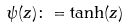<formula> <loc_0><loc_0><loc_500><loc_500>\psi ( z ) \colon = \tanh ( z )</formula> 